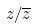<formula> <loc_0><loc_0><loc_500><loc_500>z / \overline { z }</formula> 